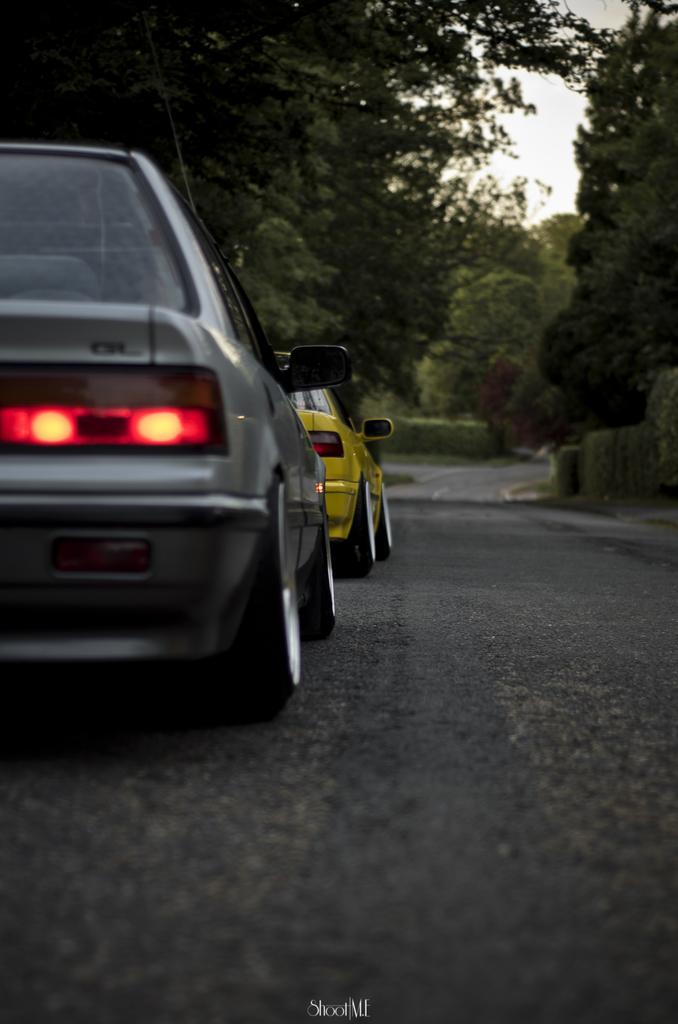What can be seen on the road in the image? There are two cars on the road in the image. What is written or displayed at the bottom of the image? There is some text at the bottom of the image. What type of vegetation is present in the image? There are trees, bushes, plants, and grass in the image. What part of the natural environment is visible in the image? The sky is visible at the top of the image. Can you tell me how many times the cars have burned in the image? There is no indication of any cars burning in the image. What type of crib is present in the image? There is no crib present in the image. 